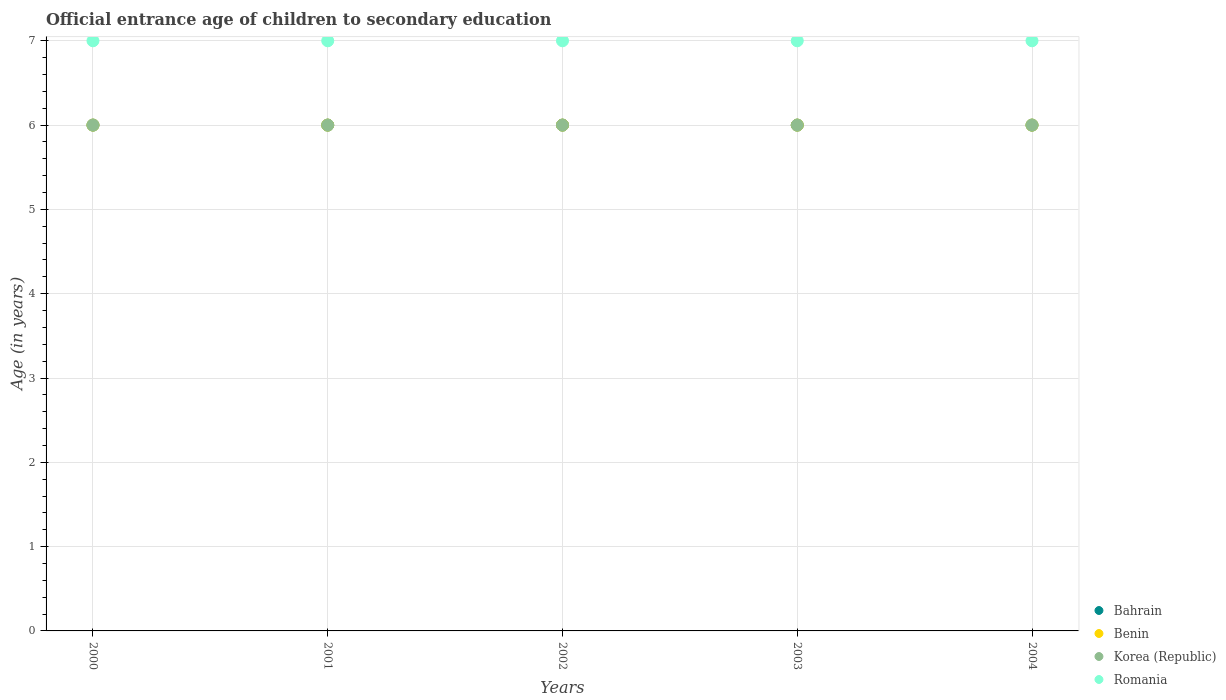What is the secondary school starting age of children in Romania in 2003?
Offer a very short reply. 7. Across all years, what is the minimum secondary school starting age of children in Korea (Republic)?
Provide a short and direct response. 6. In which year was the secondary school starting age of children in Benin maximum?
Your answer should be compact. 2000. In which year was the secondary school starting age of children in Benin minimum?
Your answer should be very brief. 2000. What is the total secondary school starting age of children in Benin in the graph?
Provide a succinct answer. 30. In the year 2004, what is the difference between the secondary school starting age of children in Benin and secondary school starting age of children in Bahrain?
Keep it short and to the point. 0. In how many years, is the secondary school starting age of children in Bahrain greater than 5.8 years?
Give a very brief answer. 5. Is the sum of the secondary school starting age of children in Bahrain in 2001 and 2004 greater than the maximum secondary school starting age of children in Benin across all years?
Keep it short and to the point. Yes. Is it the case that in every year, the sum of the secondary school starting age of children in Bahrain and secondary school starting age of children in Romania  is greater than the sum of secondary school starting age of children in Korea (Republic) and secondary school starting age of children in Benin?
Your answer should be very brief. Yes. Is the secondary school starting age of children in Benin strictly less than the secondary school starting age of children in Korea (Republic) over the years?
Your response must be concise. No. How many years are there in the graph?
Make the answer very short. 5. What is the difference between two consecutive major ticks on the Y-axis?
Provide a succinct answer. 1. Where does the legend appear in the graph?
Your answer should be compact. Bottom right. How many legend labels are there?
Give a very brief answer. 4. What is the title of the graph?
Provide a succinct answer. Official entrance age of children to secondary education. What is the label or title of the Y-axis?
Offer a very short reply. Age (in years). What is the Age (in years) in Bahrain in 2000?
Provide a succinct answer. 6. What is the Age (in years) of Bahrain in 2001?
Offer a terse response. 6. What is the Age (in years) in Benin in 2001?
Keep it short and to the point. 6. What is the Age (in years) of Romania in 2001?
Give a very brief answer. 7. What is the Age (in years) in Bahrain in 2002?
Give a very brief answer. 6. What is the Age (in years) in Benin in 2002?
Your answer should be compact. 6. What is the Age (in years) of Korea (Republic) in 2002?
Offer a very short reply. 6. What is the Age (in years) of Bahrain in 2003?
Make the answer very short. 6. What is the Age (in years) of Korea (Republic) in 2003?
Offer a very short reply. 6. What is the Age (in years) of Romania in 2003?
Give a very brief answer. 7. What is the Age (in years) in Bahrain in 2004?
Provide a succinct answer. 6. What is the Age (in years) of Korea (Republic) in 2004?
Provide a short and direct response. 6. Across all years, what is the maximum Age (in years) in Benin?
Offer a terse response. 6. Across all years, what is the maximum Age (in years) of Romania?
Ensure brevity in your answer.  7. Across all years, what is the minimum Age (in years) of Bahrain?
Make the answer very short. 6. Across all years, what is the minimum Age (in years) of Romania?
Make the answer very short. 7. What is the total Age (in years) of Bahrain in the graph?
Provide a short and direct response. 30. What is the total Age (in years) in Romania in the graph?
Offer a terse response. 35. What is the difference between the Age (in years) in Romania in 2000 and that in 2001?
Your response must be concise. 0. What is the difference between the Age (in years) of Bahrain in 2000 and that in 2002?
Provide a short and direct response. 0. What is the difference between the Age (in years) in Benin in 2000 and that in 2002?
Your response must be concise. 0. What is the difference between the Age (in years) in Bahrain in 2000 and that in 2003?
Your response must be concise. 0. What is the difference between the Age (in years) of Korea (Republic) in 2000 and that in 2003?
Provide a succinct answer. 0. What is the difference between the Age (in years) in Romania in 2000 and that in 2003?
Ensure brevity in your answer.  0. What is the difference between the Age (in years) in Benin in 2000 and that in 2004?
Ensure brevity in your answer.  0. What is the difference between the Age (in years) of Benin in 2001 and that in 2002?
Your response must be concise. 0. What is the difference between the Age (in years) of Benin in 2001 and that in 2003?
Your response must be concise. 0. What is the difference between the Age (in years) of Romania in 2001 and that in 2003?
Offer a terse response. 0. What is the difference between the Age (in years) in Bahrain in 2001 and that in 2004?
Your answer should be compact. 0. What is the difference between the Age (in years) in Korea (Republic) in 2001 and that in 2004?
Ensure brevity in your answer.  0. What is the difference between the Age (in years) of Romania in 2001 and that in 2004?
Give a very brief answer. 0. What is the difference between the Age (in years) in Korea (Republic) in 2002 and that in 2003?
Your response must be concise. 0. What is the difference between the Age (in years) of Romania in 2002 and that in 2003?
Your answer should be compact. 0. What is the difference between the Age (in years) in Bahrain in 2002 and that in 2004?
Make the answer very short. 0. What is the difference between the Age (in years) of Benin in 2002 and that in 2004?
Give a very brief answer. 0. What is the difference between the Age (in years) of Benin in 2003 and that in 2004?
Your answer should be very brief. 0. What is the difference between the Age (in years) in Korea (Republic) in 2000 and the Age (in years) in Romania in 2001?
Your answer should be very brief. -1. What is the difference between the Age (in years) of Bahrain in 2000 and the Age (in years) of Benin in 2002?
Give a very brief answer. 0. What is the difference between the Age (in years) in Bahrain in 2000 and the Age (in years) in Romania in 2002?
Keep it short and to the point. -1. What is the difference between the Age (in years) of Benin in 2000 and the Age (in years) of Korea (Republic) in 2002?
Your answer should be very brief. 0. What is the difference between the Age (in years) in Bahrain in 2000 and the Age (in years) in Benin in 2003?
Offer a very short reply. 0. What is the difference between the Age (in years) of Bahrain in 2000 and the Age (in years) of Korea (Republic) in 2003?
Your response must be concise. 0. What is the difference between the Age (in years) in Benin in 2000 and the Age (in years) in Korea (Republic) in 2003?
Keep it short and to the point. 0. What is the difference between the Age (in years) in Benin in 2000 and the Age (in years) in Romania in 2003?
Keep it short and to the point. -1. What is the difference between the Age (in years) in Bahrain in 2000 and the Age (in years) in Benin in 2004?
Your answer should be very brief. 0. What is the difference between the Age (in years) in Bahrain in 2000 and the Age (in years) in Romania in 2004?
Keep it short and to the point. -1. What is the difference between the Age (in years) of Benin in 2000 and the Age (in years) of Korea (Republic) in 2004?
Ensure brevity in your answer.  0. What is the difference between the Age (in years) in Benin in 2000 and the Age (in years) in Romania in 2004?
Give a very brief answer. -1. What is the difference between the Age (in years) of Bahrain in 2001 and the Age (in years) of Korea (Republic) in 2002?
Your answer should be compact. 0. What is the difference between the Age (in years) in Benin in 2001 and the Age (in years) in Romania in 2002?
Give a very brief answer. -1. What is the difference between the Age (in years) of Korea (Republic) in 2001 and the Age (in years) of Romania in 2002?
Give a very brief answer. -1. What is the difference between the Age (in years) in Bahrain in 2001 and the Age (in years) in Korea (Republic) in 2003?
Keep it short and to the point. 0. What is the difference between the Age (in years) of Bahrain in 2001 and the Age (in years) of Romania in 2003?
Keep it short and to the point. -1. What is the difference between the Age (in years) in Benin in 2001 and the Age (in years) in Korea (Republic) in 2003?
Offer a terse response. 0. What is the difference between the Age (in years) in Bahrain in 2001 and the Age (in years) in Korea (Republic) in 2004?
Offer a very short reply. 0. What is the difference between the Age (in years) in Bahrain in 2001 and the Age (in years) in Romania in 2004?
Your answer should be very brief. -1. What is the difference between the Age (in years) of Benin in 2001 and the Age (in years) of Korea (Republic) in 2004?
Provide a short and direct response. 0. What is the difference between the Age (in years) in Benin in 2001 and the Age (in years) in Romania in 2004?
Make the answer very short. -1. What is the difference between the Age (in years) in Bahrain in 2002 and the Age (in years) in Romania in 2003?
Your answer should be compact. -1. What is the difference between the Age (in years) in Benin in 2002 and the Age (in years) in Romania in 2003?
Ensure brevity in your answer.  -1. What is the difference between the Age (in years) in Korea (Republic) in 2002 and the Age (in years) in Romania in 2003?
Offer a very short reply. -1. What is the difference between the Age (in years) of Bahrain in 2002 and the Age (in years) of Korea (Republic) in 2004?
Provide a short and direct response. 0. What is the difference between the Age (in years) in Benin in 2002 and the Age (in years) in Korea (Republic) in 2004?
Your answer should be compact. 0. What is the difference between the Age (in years) in Benin in 2002 and the Age (in years) in Romania in 2004?
Your response must be concise. -1. What is the difference between the Age (in years) in Bahrain in 2003 and the Age (in years) in Korea (Republic) in 2004?
Ensure brevity in your answer.  0. What is the difference between the Age (in years) in Benin in 2003 and the Age (in years) in Romania in 2004?
Make the answer very short. -1. What is the average Age (in years) of Benin per year?
Provide a short and direct response. 6. What is the average Age (in years) of Romania per year?
Provide a succinct answer. 7. In the year 2000, what is the difference between the Age (in years) of Bahrain and Age (in years) of Benin?
Provide a short and direct response. 0. In the year 2000, what is the difference between the Age (in years) of Bahrain and Age (in years) of Korea (Republic)?
Your answer should be very brief. 0. In the year 2000, what is the difference between the Age (in years) in Bahrain and Age (in years) in Romania?
Your response must be concise. -1. In the year 2000, what is the difference between the Age (in years) of Korea (Republic) and Age (in years) of Romania?
Provide a short and direct response. -1. In the year 2001, what is the difference between the Age (in years) in Benin and Age (in years) in Romania?
Give a very brief answer. -1. In the year 2002, what is the difference between the Age (in years) in Bahrain and Age (in years) in Benin?
Ensure brevity in your answer.  0. In the year 2002, what is the difference between the Age (in years) in Bahrain and Age (in years) in Romania?
Ensure brevity in your answer.  -1. In the year 2003, what is the difference between the Age (in years) in Bahrain and Age (in years) in Romania?
Keep it short and to the point. -1. In the year 2003, what is the difference between the Age (in years) of Benin and Age (in years) of Romania?
Offer a very short reply. -1. In the year 2003, what is the difference between the Age (in years) of Korea (Republic) and Age (in years) of Romania?
Provide a short and direct response. -1. In the year 2004, what is the difference between the Age (in years) of Bahrain and Age (in years) of Benin?
Give a very brief answer. 0. In the year 2004, what is the difference between the Age (in years) of Bahrain and Age (in years) of Korea (Republic)?
Offer a very short reply. 0. In the year 2004, what is the difference between the Age (in years) of Bahrain and Age (in years) of Romania?
Give a very brief answer. -1. In the year 2004, what is the difference between the Age (in years) in Benin and Age (in years) in Korea (Republic)?
Ensure brevity in your answer.  0. In the year 2004, what is the difference between the Age (in years) in Benin and Age (in years) in Romania?
Ensure brevity in your answer.  -1. In the year 2004, what is the difference between the Age (in years) of Korea (Republic) and Age (in years) of Romania?
Offer a very short reply. -1. What is the ratio of the Age (in years) in Romania in 2000 to that in 2001?
Offer a very short reply. 1. What is the ratio of the Age (in years) of Korea (Republic) in 2000 to that in 2002?
Give a very brief answer. 1. What is the ratio of the Age (in years) of Romania in 2000 to that in 2002?
Ensure brevity in your answer.  1. What is the ratio of the Age (in years) of Benin in 2000 to that in 2003?
Your response must be concise. 1. What is the ratio of the Age (in years) of Bahrain in 2000 to that in 2004?
Ensure brevity in your answer.  1. What is the ratio of the Age (in years) of Benin in 2000 to that in 2004?
Your answer should be compact. 1. What is the ratio of the Age (in years) of Korea (Republic) in 2000 to that in 2004?
Offer a terse response. 1. What is the ratio of the Age (in years) of Romania in 2001 to that in 2002?
Your answer should be compact. 1. What is the ratio of the Age (in years) in Korea (Republic) in 2001 to that in 2003?
Keep it short and to the point. 1. What is the ratio of the Age (in years) in Benin in 2001 to that in 2004?
Keep it short and to the point. 1. What is the ratio of the Age (in years) in Korea (Republic) in 2001 to that in 2004?
Provide a succinct answer. 1. What is the ratio of the Age (in years) in Korea (Republic) in 2002 to that in 2003?
Your response must be concise. 1. What is the ratio of the Age (in years) of Romania in 2002 to that in 2003?
Your answer should be very brief. 1. What is the ratio of the Age (in years) in Korea (Republic) in 2002 to that in 2004?
Make the answer very short. 1. What is the ratio of the Age (in years) in Korea (Republic) in 2003 to that in 2004?
Provide a succinct answer. 1. What is the ratio of the Age (in years) in Romania in 2003 to that in 2004?
Keep it short and to the point. 1. What is the difference between the highest and the second highest Age (in years) of Bahrain?
Your answer should be compact. 0. What is the difference between the highest and the second highest Age (in years) of Korea (Republic)?
Provide a short and direct response. 0. What is the difference between the highest and the lowest Age (in years) of Bahrain?
Give a very brief answer. 0. What is the difference between the highest and the lowest Age (in years) in Korea (Republic)?
Ensure brevity in your answer.  0. 